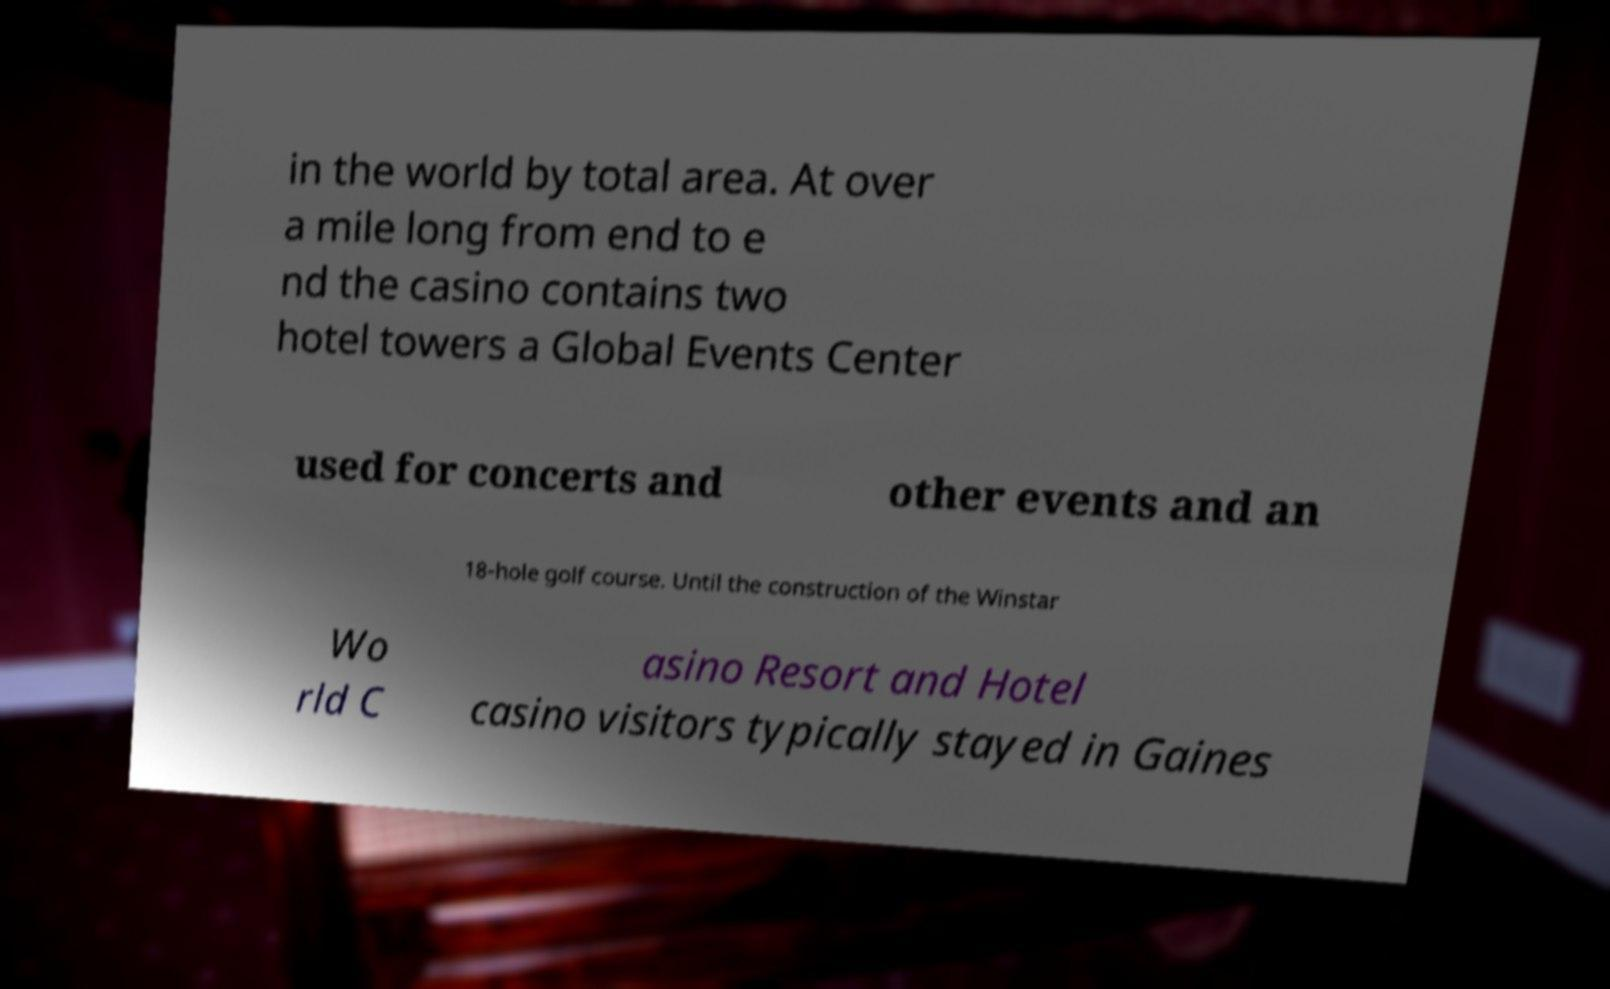Could you extract and type out the text from this image? in the world by total area. At over a mile long from end to e nd the casino contains two hotel towers a Global Events Center used for concerts and other events and an 18-hole golf course. Until the construction of the Winstar Wo rld C asino Resort and Hotel casino visitors typically stayed in Gaines 